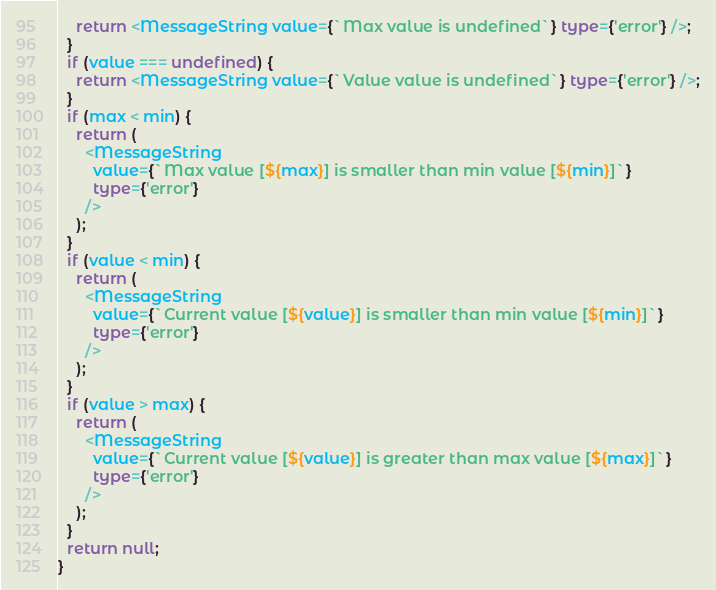Convert code to text. <code><loc_0><loc_0><loc_500><loc_500><_TypeScript_>    return <MessageString value={`Max value is undefined`} type={'error'} />;
  }
  if (value === undefined) {
    return <MessageString value={`Value value is undefined`} type={'error'} />;
  }
  if (max < min) {
    return (
      <MessageString
        value={`Max value [${max}] is smaller than min value [${min}]`}
        type={'error'}
      />
    );
  }
  if (value < min) {
    return (
      <MessageString
        value={`Current value [${value}] is smaller than min value [${min}]`}
        type={'error'}
      />
    );
  }
  if (value > max) {
    return (
      <MessageString
        value={`Current value [${value}] is greater than max value [${max}]`}
        type={'error'}
      />
    );
  }
  return null;
}
</code> 